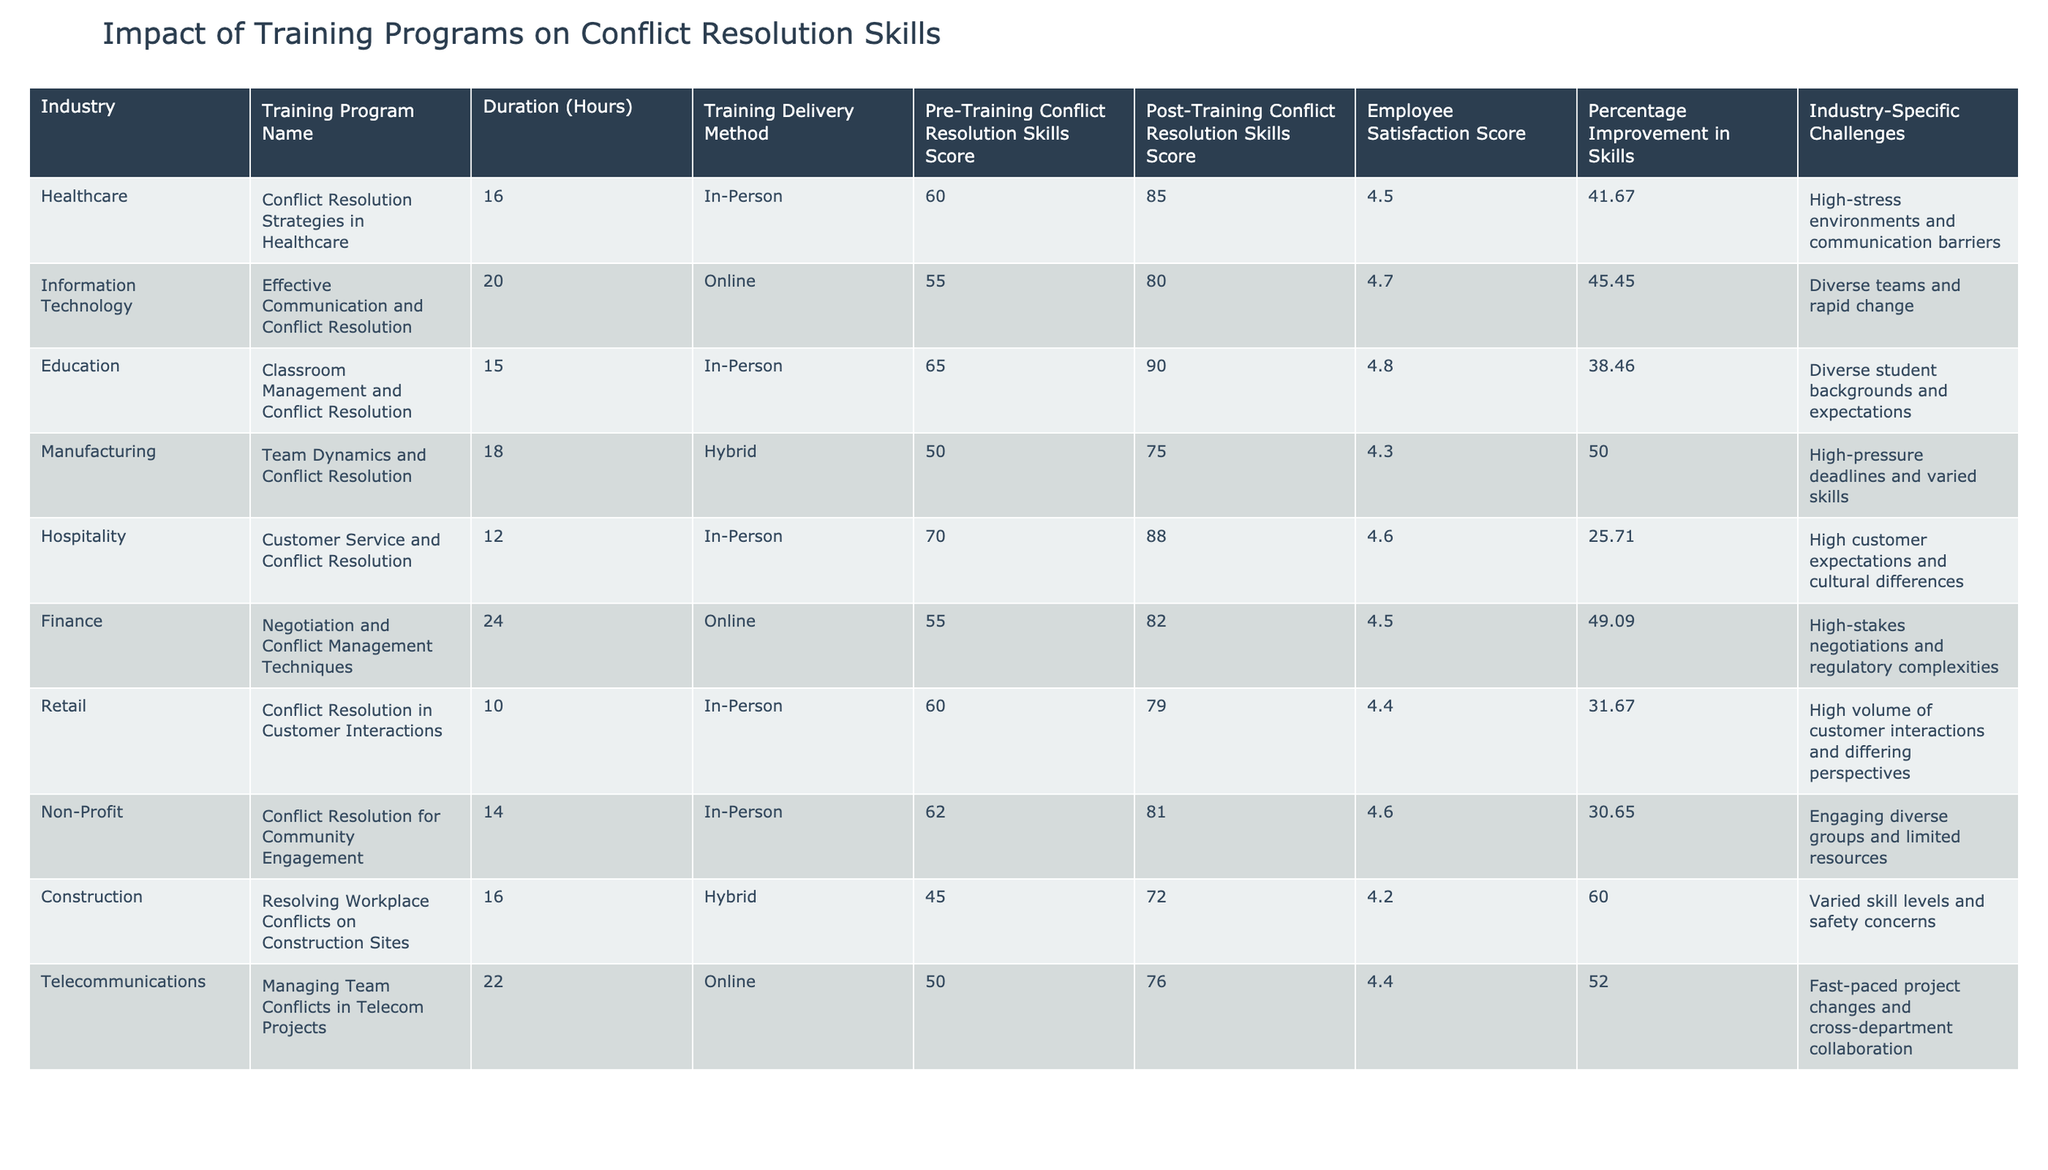What is the highest post-training conflict resolution skills score? To find the highest post-training conflict resolution skills score, we look at the "Post-Training Conflict Resolution Skills Score" column. The highest value is 90 from the Education industry.
Answer: 90 Which training program had the longest duration? Reviewing the "Duration (Hours)" column, we see that the Finance training program has the longest duration at 24 hours.
Answer: 24 hours What percentage improvement in skills did the Manufacturing industry see? Looking at the "Percentage Improvement in Skills" column, the Manufacturing industry shows a 50.00% improvement.
Answer: 50.00% Is the Employee Satisfaction Score for the Hospitality industry above 4.5? The Hospitality industry has an Employee Satisfaction Score of 4.6, which is above 4.5, so the answer is yes.
Answer: Yes How many industries had a percentage improvement in skills greater than 40%? By reviewing the "Percentage Improvement in Skills" column, the industries with more than 40% improvement are Healthcare, Information Technology, Manufacturing, Finance, Telecommunications, and Construction. That makes a total of 6 industries.
Answer: 6 What is the average pre-training conflict resolution skills score of all industries? We sum all the pre-training scores: (60 + 55 + 65 + 50 + 70 + 55 + 60 + 62 + 45 + 50) =  682. There are 10 industries, so the average is 682/10 = 68.2.
Answer: 68.2 Which industry had the greatest percentage improvement, and what was that percentage? By evaluating the "Percentage Improvement in Skills" column, we see that the Construction industry had the highest percentage improvement at 60.00%.
Answer: Construction, 60.00% Was the training delivery method for the Non-Profit industry in-person? The "Training Delivery Method" column shows that the Non-Profit industry conducted their training in-person, so the answer is yes.
Answer: Yes Is the Employee Satisfaction Score in the Education industry the highest among all listed industries? The Education industry has a satisfaction score of 4.8. By comparing it to the other scores, it is indeed the highest.
Answer: Yes 